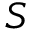Convert formula to latex. <formula><loc_0><loc_0><loc_500><loc_500>S</formula> 